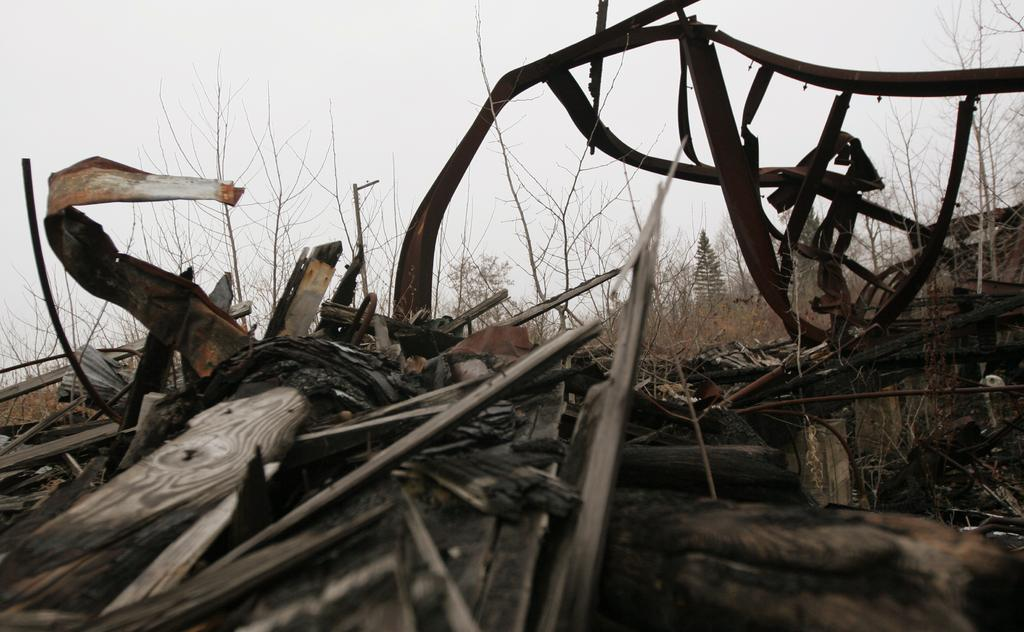What type of vegetation can be seen in the image? There are plants and grass in the image. What materials are used for the sticks in the image? The sticks in the image are made of wood. What type of construction material is present in the image? There are iron rods in the image. What part of the natural environment is visible in the image? The sky is visible in the image. What type of oatmeal is being served in the image? There is no oatmeal present in the image. Can you identify any cactus plants in the image? There are no cactus plants visible in the image. 